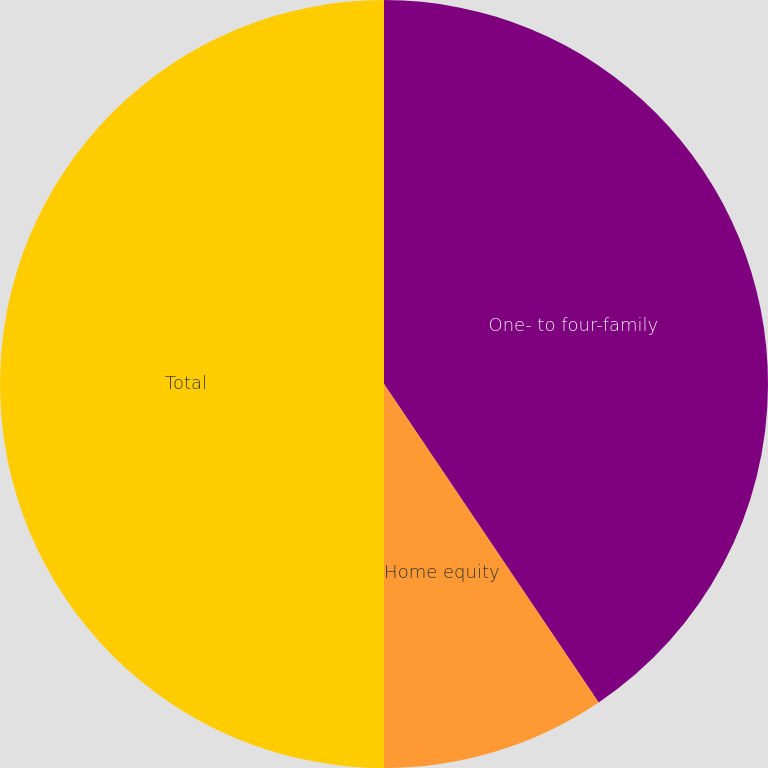<chart> <loc_0><loc_0><loc_500><loc_500><pie_chart><fcel>One- to four-family<fcel>Home equity<fcel>Total<nl><fcel>40.56%<fcel>9.44%<fcel>50.0%<nl></chart> 